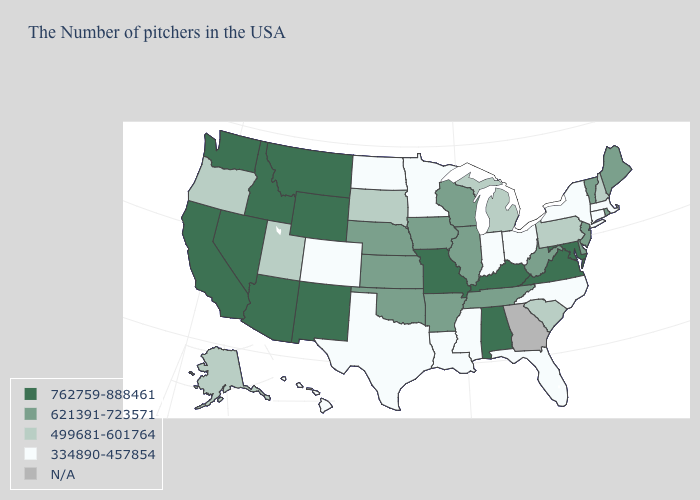Does the first symbol in the legend represent the smallest category?
Give a very brief answer. No. Which states hav the highest value in the South?
Give a very brief answer. Maryland, Virginia, Kentucky, Alabama. What is the value of New Jersey?
Be succinct. 621391-723571. Name the states that have a value in the range 334890-457854?
Write a very short answer. Massachusetts, Connecticut, New York, North Carolina, Ohio, Florida, Indiana, Mississippi, Louisiana, Minnesota, Texas, North Dakota, Colorado, Hawaii. Does the first symbol in the legend represent the smallest category?
Answer briefly. No. What is the highest value in states that border Massachusetts?
Keep it brief. 621391-723571. Which states have the lowest value in the USA?
Answer briefly. Massachusetts, Connecticut, New York, North Carolina, Ohio, Florida, Indiana, Mississippi, Louisiana, Minnesota, Texas, North Dakota, Colorado, Hawaii. Name the states that have a value in the range 621391-723571?
Concise answer only. Maine, Rhode Island, Vermont, New Jersey, Delaware, West Virginia, Tennessee, Wisconsin, Illinois, Arkansas, Iowa, Kansas, Nebraska, Oklahoma. Among the states that border Oklahoma , does Kansas have the lowest value?
Be succinct. No. Among the states that border Minnesota , does Iowa have the highest value?
Short answer required. Yes. Name the states that have a value in the range 621391-723571?
Concise answer only. Maine, Rhode Island, Vermont, New Jersey, Delaware, West Virginia, Tennessee, Wisconsin, Illinois, Arkansas, Iowa, Kansas, Nebraska, Oklahoma. Name the states that have a value in the range 762759-888461?
Answer briefly. Maryland, Virginia, Kentucky, Alabama, Missouri, Wyoming, New Mexico, Montana, Arizona, Idaho, Nevada, California, Washington. Does Arizona have the highest value in the USA?
Give a very brief answer. Yes. 